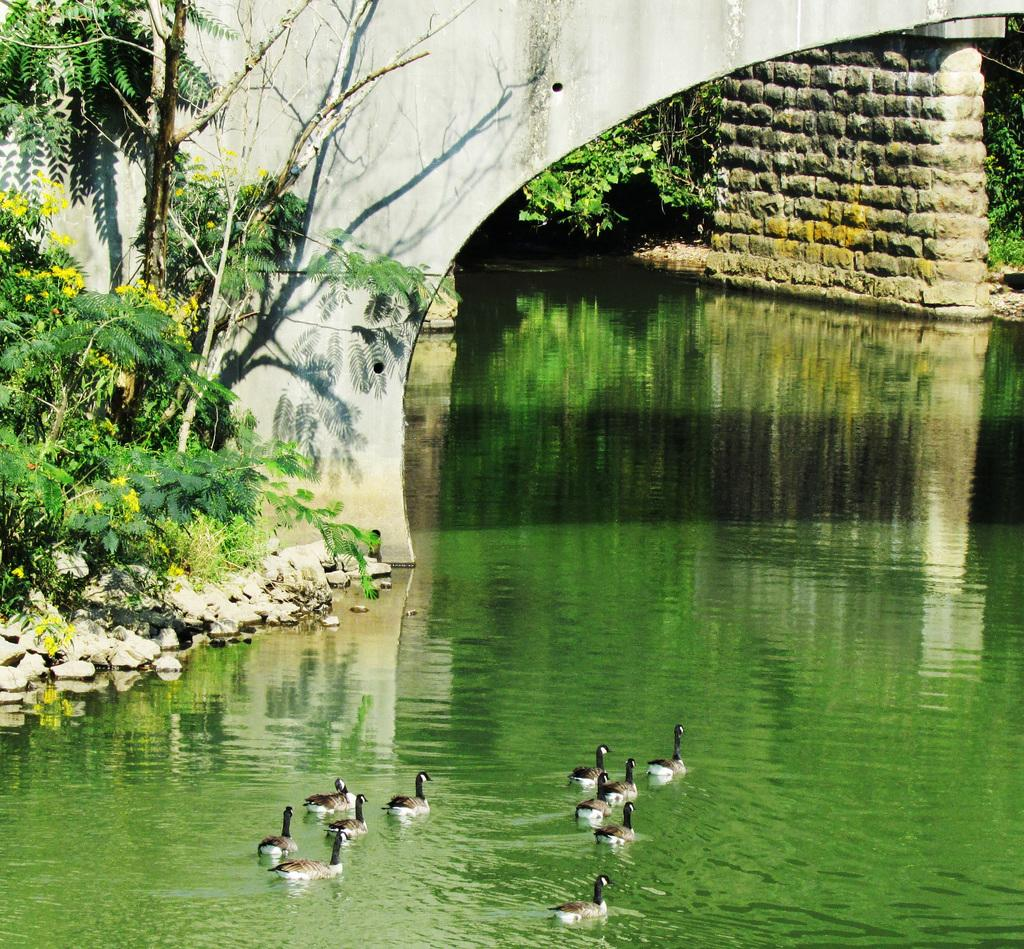What animals can be seen in the image? There are birds on a water body in the image. What type of structure is present in the image? There is a bridge in the image. What can be seen in the background of the image? There are trees in the background of the image. Where is the faucet located in the image? There is no faucet present in the image. What level of the building can be seen in the image? There is no building present in the image. 